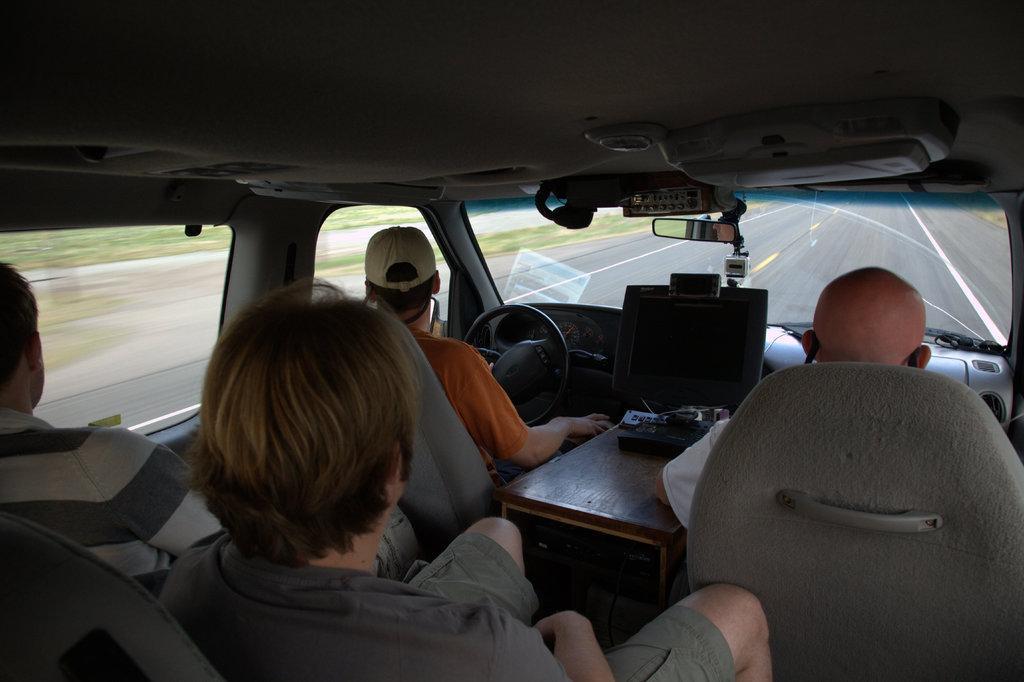Can you describe this image briefly? This is the inside view of the vehicle. In this image we can see some people, mirror, monitor, steering, glass window and other objects. Behind the vehicle there is a road, grass and other objects. 